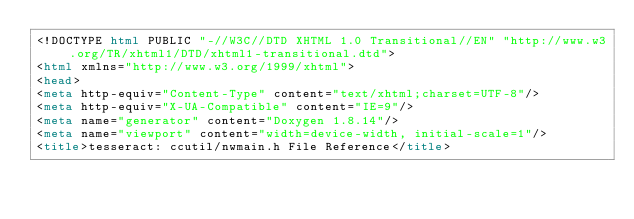Convert code to text. <code><loc_0><loc_0><loc_500><loc_500><_HTML_><!DOCTYPE html PUBLIC "-//W3C//DTD XHTML 1.0 Transitional//EN" "http://www.w3.org/TR/xhtml1/DTD/xhtml1-transitional.dtd">
<html xmlns="http://www.w3.org/1999/xhtml">
<head>
<meta http-equiv="Content-Type" content="text/xhtml;charset=UTF-8"/>
<meta http-equiv="X-UA-Compatible" content="IE=9"/>
<meta name="generator" content="Doxygen 1.8.14"/>
<meta name="viewport" content="width=device-width, initial-scale=1"/>
<title>tesseract: ccutil/nwmain.h File Reference</title></code> 